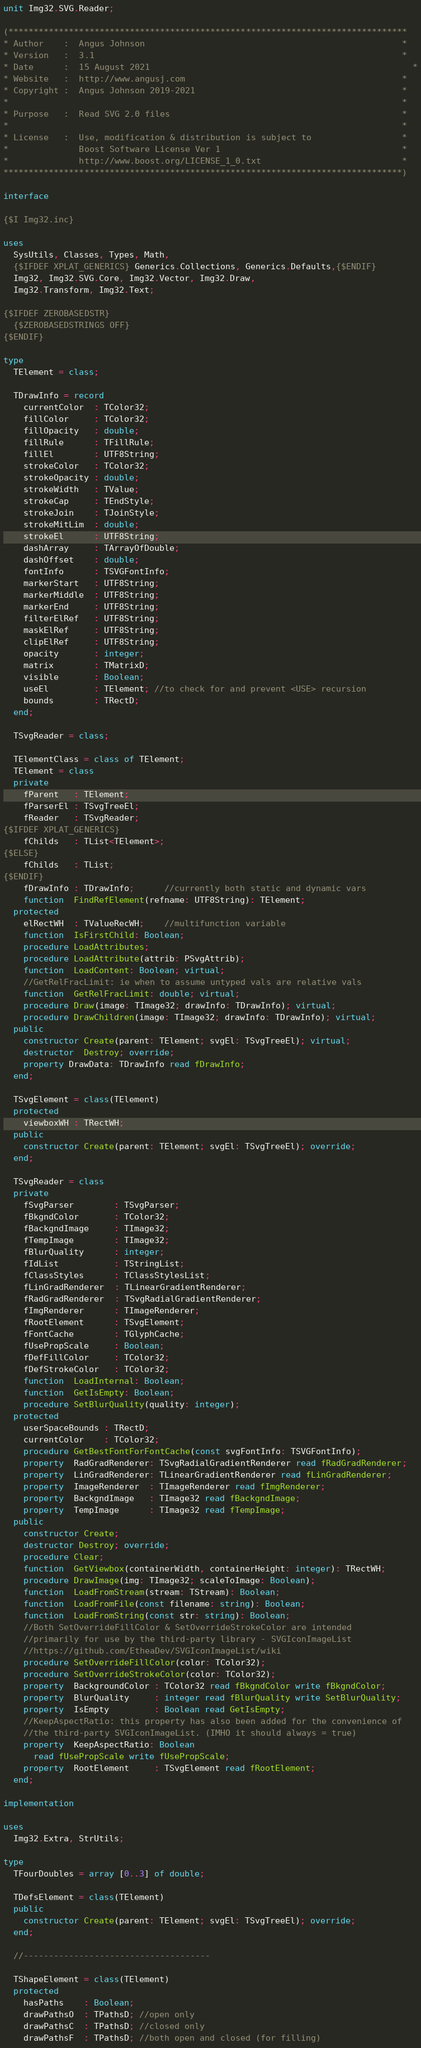Convert code to text. <code><loc_0><loc_0><loc_500><loc_500><_Pascal_>unit Img32.SVG.Reader;

(*******************************************************************************
* Author    :  Angus Johnson                                                   *
* Version   :  3.1                                                             *
* Date      :  15 August 2021                                                    *
* Website   :  http://www.angusj.com                                           *
* Copyright :  Angus Johnson 2019-2021                                         *
*                                                                              *
* Purpose   :  Read SVG 2.0 files                                              *
*                                                                              *
* License   :  Use, modification & distribution is subject to                  *
*              Boost Software License Ver 1                                    *
*              http://www.boost.org/LICENSE_1_0.txt                            *
*******************************************************************************)

interface

{$I Img32.inc}

uses
  SysUtils, Classes, Types, Math,
  {$IFDEF XPLAT_GENERICS} Generics.Collections, Generics.Defaults,{$ENDIF}
  Img32, Img32.SVG.Core, Img32.Vector, Img32.Draw,
  Img32.Transform, Img32.Text;

{$IFDEF ZEROBASEDSTR}
  {$ZEROBASEDSTRINGS OFF}
{$ENDIF}

type
  TElement = class;

  TDrawInfo = record
    currentColor  : TColor32;
    fillColor     : TColor32;
    fillOpacity   : double;
    fillRule      : TFillRule;
    fillEl        : UTF8String;
    strokeColor   : TColor32;
    strokeOpacity : double;
    strokeWidth   : TValue;
    strokeCap     : TEndStyle;
    strokeJoin    : TJoinStyle;
    strokeMitLim  : double;
    strokeEl      : UTF8String;
    dashArray     : TArrayOfDouble;
    dashOffset    : double;
    fontInfo      : TSVGFontInfo;
    markerStart   : UTF8String;
    markerMiddle  : UTF8String;
    markerEnd     : UTF8String;
    filterElRef   : UTF8String;
    maskElRef     : UTF8String;
    clipElRef     : UTF8String;
    opacity       : integer;
    matrix        : TMatrixD;
    visible       : Boolean;
    useEl         : TElement; //to check for and prevent <USE> recursion
    bounds        : TRectD;
  end;

  TSvgReader = class;

  TElementClass = class of TElement;
  TElement = class
  private
    fParent   : TElement;
    fParserEl : TSvgTreeEl;
    fReader   : TSvgReader;
{$IFDEF XPLAT_GENERICS}
    fChilds   : TList<TElement>;
{$ELSE}
    fChilds   : TList;
{$ENDIF}
    fDrawInfo : TDrawInfo;      //currently both static and dynamic vars
    function  FindRefElement(refname: UTF8String): TElement;
  protected
    elRectWH  : TValueRecWH;    //multifunction variable
    function  IsFirstChild: Boolean;
    procedure LoadAttributes;
    procedure LoadAttribute(attrib: PSvgAttrib);
    function  LoadContent: Boolean; virtual;
    //GetRelFracLimit: ie when to assume untyped vals are relative vals
    function  GetRelFracLimit: double; virtual;
    procedure Draw(image: TImage32; drawInfo: TDrawInfo); virtual;
    procedure DrawChildren(image: TImage32; drawInfo: TDrawInfo); virtual;
  public
    constructor Create(parent: TElement; svgEl: TSvgTreeEl); virtual;
    destructor  Destroy; override;
    property DrawData: TDrawInfo read fDrawInfo;
  end;

  TSvgElement = class(TElement)
  protected
    viewboxWH : TRectWH;
  public
    constructor Create(parent: TElement; svgEl: TSvgTreeEl); override;
  end;

  TSvgReader = class
  private
    fSvgParser        : TSvgParser;
    fBkgndColor       : TColor32;
    fBackgndImage     : TImage32;
    fTempImage        : TImage32;
    fBlurQuality      : integer;
    fIdList           : TStringList;
    fClassStyles      : TClassStylesList;
    fLinGradRenderer  : TLinearGradientRenderer;
    fRadGradRenderer  : TSvgRadialGradientRenderer;
    fImgRenderer      : TImageRenderer;
    fRootElement      : TSvgElement;
    fFontCache        : TGlyphCache;
    fUsePropScale     : Boolean;
    fDefFillColor     : TColor32;
    fDefStrokeColor   : TColor32;
    function  LoadInternal: Boolean;
    function  GetIsEmpty: Boolean;
    procedure SetBlurQuality(quality: integer);
  protected
    userSpaceBounds : TRectD;
    currentColor    : TColor32;
    procedure GetBestFontForFontCache(const svgFontInfo: TSVGFontInfo);
    property  RadGradRenderer: TSvgRadialGradientRenderer read fRadGradRenderer;
    property  LinGradRenderer: TLinearGradientRenderer read fLinGradRenderer;
    property  ImageRenderer  : TImageRenderer read fImgRenderer;
    property  BackgndImage   : TImage32 read fBackgndImage;
    property  TempImage      : TImage32 read fTempImage;
  public
    constructor Create;
    destructor Destroy; override;
    procedure Clear;
    function  GetViewbox(containerWidth, containerHeight: integer): TRectWH;
    procedure DrawImage(img: TImage32; scaleToImage: Boolean);
    function  LoadFromStream(stream: TStream): Boolean;
    function  LoadFromFile(const filename: string): Boolean;
    function  LoadFromString(const str: string): Boolean;
    //Both SetOverrideFillColor & SetOverrideStrokeColor are intended
    //primarily for use by the third-party library - SVGIconImageList
    //https://github.com/EtheaDev/SVGIconImageList/wiki
    procedure SetOverrideFillColor(color: TColor32);
    procedure SetOverrideStrokeColor(color: TColor32);
    property  BackgroundColor : TColor32 read fBkgndColor write fBkgndColor;
    property  BlurQuality     : integer read fBlurQuality write SetBlurQuality;
    property  IsEmpty         : Boolean read GetIsEmpty;
    //KeepAspectRatio: this property has also been added for the convenience of
    //the third-party SVGIconImageList. (IMHO it should always = true)
    property  KeepAspectRatio: Boolean
      read fUsePropScale write fUsePropScale;
    property  RootElement     : TSvgElement read fRootElement;
  end;

implementation

uses
  Img32.Extra, StrUtils;

type
  TFourDoubles = array [0..3] of double;

  TDefsElement = class(TElement)
  public
    constructor Create(parent: TElement; svgEl: TSvgTreeEl); override;
  end;

  //-------------------------------------

  TShapeElement = class(TElement)
  protected
    hasPaths    : Boolean;
    drawPathsO  : TPathsD; //open only
    drawPathsC  : TPathsD; //closed only
    drawPathsF  : TPathsD; //both open and closed (for filling)</code> 